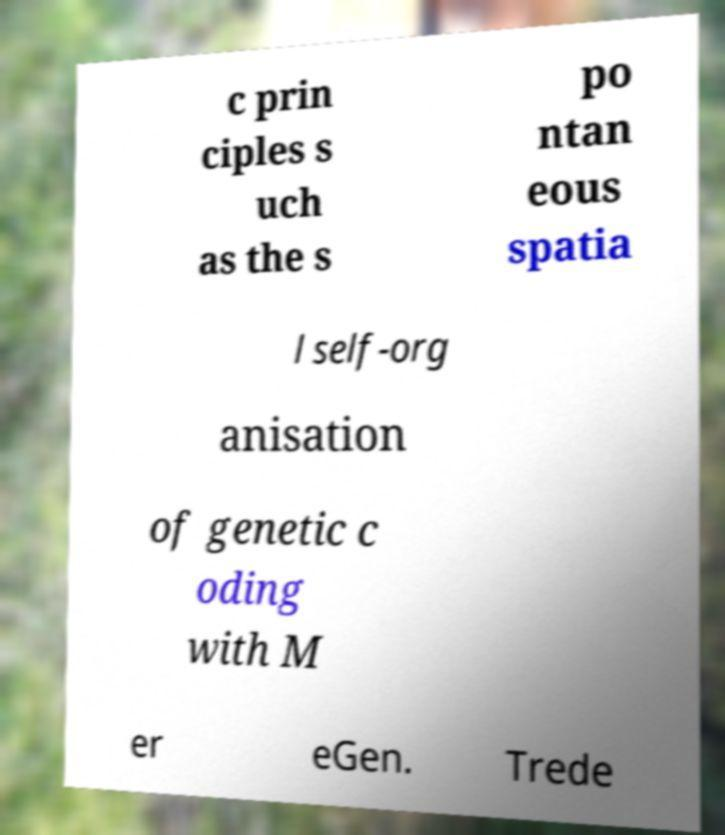For documentation purposes, I need the text within this image transcribed. Could you provide that? c prin ciples s uch as the s po ntan eous spatia l self-org anisation of genetic c oding with M er eGen. Trede 